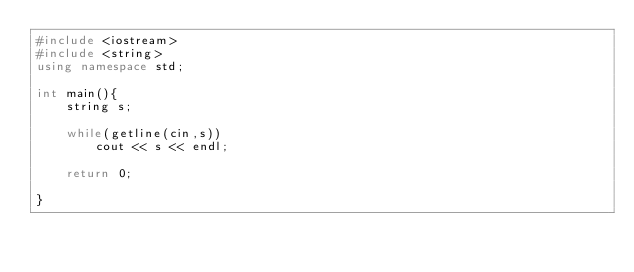Convert code to text. <code><loc_0><loc_0><loc_500><loc_500><_C++_>#include <iostream>
#include <string>
using namespace std;

int main(){
	string s;
	
	while(getline(cin,s))
		cout << s << endl;
	
	return 0;

}
</code> 